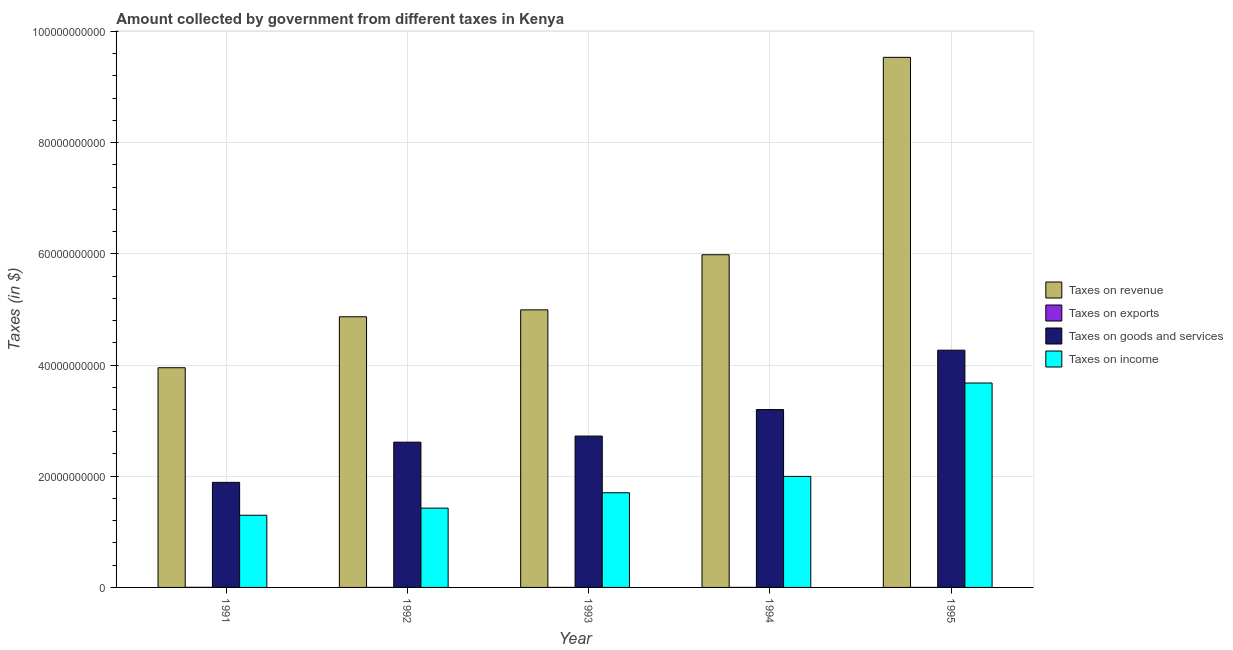Are the number of bars per tick equal to the number of legend labels?
Your answer should be compact. Yes. Are the number of bars on each tick of the X-axis equal?
Your response must be concise. Yes. In how many cases, is the number of bars for a given year not equal to the number of legend labels?
Your answer should be compact. 0. What is the amount collected as tax on income in 1991?
Offer a terse response. 1.30e+1. Across all years, what is the maximum amount collected as tax on goods?
Keep it short and to the point. 4.27e+1. Across all years, what is the minimum amount collected as tax on revenue?
Keep it short and to the point. 3.95e+1. In which year was the amount collected as tax on exports minimum?
Ensure brevity in your answer.  1993. What is the total amount collected as tax on income in the graph?
Offer a terse response. 1.01e+11. What is the difference between the amount collected as tax on goods in 1993 and that in 1994?
Keep it short and to the point. -4.77e+09. What is the difference between the amount collected as tax on goods in 1992 and the amount collected as tax on income in 1993?
Offer a terse response. -1.10e+09. What is the average amount collected as tax on revenue per year?
Offer a very short reply. 5.87e+1. In the year 1995, what is the difference between the amount collected as tax on goods and amount collected as tax on exports?
Your response must be concise. 0. In how many years, is the amount collected as tax on exports greater than 44000000000 $?
Your answer should be very brief. 0. What is the ratio of the amount collected as tax on goods in 1992 to that in 1995?
Keep it short and to the point. 0.61. Is the difference between the amount collected as tax on exports in 1993 and 1994 greater than the difference between the amount collected as tax on goods in 1993 and 1994?
Your answer should be compact. No. What is the difference between the highest and the second highest amount collected as tax on goods?
Offer a very short reply. 1.07e+1. What is the difference between the highest and the lowest amount collected as tax on income?
Your answer should be compact. 2.38e+1. What does the 4th bar from the left in 1993 represents?
Provide a succinct answer. Taxes on income. What does the 2nd bar from the right in 1995 represents?
Make the answer very short. Taxes on goods and services. Is it the case that in every year, the sum of the amount collected as tax on revenue and amount collected as tax on exports is greater than the amount collected as tax on goods?
Keep it short and to the point. Yes. How many years are there in the graph?
Your answer should be very brief. 5. Are the values on the major ticks of Y-axis written in scientific E-notation?
Make the answer very short. No. Where does the legend appear in the graph?
Provide a succinct answer. Center right. What is the title of the graph?
Ensure brevity in your answer.  Amount collected by government from different taxes in Kenya. What is the label or title of the X-axis?
Make the answer very short. Year. What is the label or title of the Y-axis?
Provide a short and direct response. Taxes (in $). What is the Taxes (in $) in Taxes on revenue in 1991?
Provide a succinct answer. 3.95e+1. What is the Taxes (in $) of Taxes on exports in 1991?
Make the answer very short. 1.50e+07. What is the Taxes (in $) in Taxes on goods and services in 1991?
Offer a very short reply. 1.89e+1. What is the Taxes (in $) in Taxes on income in 1991?
Your answer should be compact. 1.30e+1. What is the Taxes (in $) in Taxes on revenue in 1992?
Ensure brevity in your answer.  4.87e+1. What is the Taxes (in $) of Taxes on goods and services in 1992?
Make the answer very short. 2.61e+1. What is the Taxes (in $) of Taxes on income in 1992?
Ensure brevity in your answer.  1.43e+1. What is the Taxes (in $) of Taxes on revenue in 1993?
Make the answer very short. 4.99e+1. What is the Taxes (in $) of Taxes on goods and services in 1993?
Keep it short and to the point. 2.72e+1. What is the Taxes (in $) in Taxes on income in 1993?
Ensure brevity in your answer.  1.70e+1. What is the Taxes (in $) in Taxes on revenue in 1994?
Keep it short and to the point. 5.98e+1. What is the Taxes (in $) in Taxes on goods and services in 1994?
Make the answer very short. 3.20e+1. What is the Taxes (in $) of Taxes on income in 1994?
Make the answer very short. 2.00e+1. What is the Taxes (in $) in Taxes on revenue in 1995?
Offer a very short reply. 9.54e+1. What is the Taxes (in $) in Taxes on goods and services in 1995?
Provide a succinct answer. 4.27e+1. What is the Taxes (in $) in Taxes on income in 1995?
Make the answer very short. 3.68e+1. Across all years, what is the maximum Taxes (in $) of Taxes on revenue?
Give a very brief answer. 9.54e+1. Across all years, what is the maximum Taxes (in $) of Taxes on exports?
Your answer should be very brief. 1.50e+07. Across all years, what is the maximum Taxes (in $) in Taxes on goods and services?
Provide a short and direct response. 4.27e+1. Across all years, what is the maximum Taxes (in $) in Taxes on income?
Offer a very short reply. 3.68e+1. Across all years, what is the minimum Taxes (in $) in Taxes on revenue?
Your answer should be compact. 3.95e+1. Across all years, what is the minimum Taxes (in $) in Taxes on exports?
Offer a terse response. 1.00e+06. Across all years, what is the minimum Taxes (in $) of Taxes on goods and services?
Provide a short and direct response. 1.89e+1. Across all years, what is the minimum Taxes (in $) in Taxes on income?
Ensure brevity in your answer.  1.30e+1. What is the total Taxes (in $) of Taxes on revenue in the graph?
Keep it short and to the point. 2.93e+11. What is the total Taxes (in $) in Taxes on exports in the graph?
Your answer should be compact. 2.50e+07. What is the total Taxes (in $) of Taxes on goods and services in the graph?
Give a very brief answer. 1.47e+11. What is the total Taxes (in $) in Taxes on income in the graph?
Your answer should be compact. 1.01e+11. What is the difference between the Taxes (in $) in Taxes on revenue in 1991 and that in 1992?
Keep it short and to the point. -9.16e+09. What is the difference between the Taxes (in $) in Taxes on exports in 1991 and that in 1992?
Your answer should be very brief. 1.30e+07. What is the difference between the Taxes (in $) of Taxes on goods and services in 1991 and that in 1992?
Give a very brief answer. -7.23e+09. What is the difference between the Taxes (in $) in Taxes on income in 1991 and that in 1992?
Give a very brief answer. -1.28e+09. What is the difference between the Taxes (in $) of Taxes on revenue in 1991 and that in 1993?
Ensure brevity in your answer.  -1.04e+1. What is the difference between the Taxes (in $) in Taxes on exports in 1991 and that in 1993?
Your answer should be very brief. 1.40e+07. What is the difference between the Taxes (in $) of Taxes on goods and services in 1991 and that in 1993?
Your answer should be compact. -8.33e+09. What is the difference between the Taxes (in $) of Taxes on income in 1991 and that in 1993?
Your answer should be very brief. -4.04e+09. What is the difference between the Taxes (in $) in Taxes on revenue in 1991 and that in 1994?
Make the answer very short. -2.03e+1. What is the difference between the Taxes (in $) of Taxes on exports in 1991 and that in 1994?
Make the answer very short. 1.10e+07. What is the difference between the Taxes (in $) of Taxes on goods and services in 1991 and that in 1994?
Provide a succinct answer. -1.31e+1. What is the difference between the Taxes (in $) in Taxes on income in 1991 and that in 1994?
Your answer should be compact. -6.99e+09. What is the difference between the Taxes (in $) of Taxes on revenue in 1991 and that in 1995?
Keep it short and to the point. -5.58e+1. What is the difference between the Taxes (in $) of Taxes on goods and services in 1991 and that in 1995?
Ensure brevity in your answer.  -2.38e+1. What is the difference between the Taxes (in $) in Taxes on income in 1991 and that in 1995?
Your response must be concise. -2.38e+1. What is the difference between the Taxes (in $) in Taxes on revenue in 1992 and that in 1993?
Your answer should be very brief. -1.24e+09. What is the difference between the Taxes (in $) in Taxes on exports in 1992 and that in 1993?
Your answer should be compact. 1.00e+06. What is the difference between the Taxes (in $) in Taxes on goods and services in 1992 and that in 1993?
Your answer should be very brief. -1.10e+09. What is the difference between the Taxes (in $) in Taxes on income in 1992 and that in 1993?
Provide a succinct answer. -2.77e+09. What is the difference between the Taxes (in $) in Taxes on revenue in 1992 and that in 1994?
Your answer should be compact. -1.12e+1. What is the difference between the Taxes (in $) of Taxes on goods and services in 1992 and that in 1994?
Ensure brevity in your answer.  -5.86e+09. What is the difference between the Taxes (in $) of Taxes on income in 1992 and that in 1994?
Ensure brevity in your answer.  -5.71e+09. What is the difference between the Taxes (in $) of Taxes on revenue in 1992 and that in 1995?
Give a very brief answer. -4.67e+1. What is the difference between the Taxes (in $) in Taxes on exports in 1992 and that in 1995?
Your response must be concise. -1.00e+06. What is the difference between the Taxes (in $) in Taxes on goods and services in 1992 and that in 1995?
Provide a short and direct response. -1.65e+1. What is the difference between the Taxes (in $) in Taxes on income in 1992 and that in 1995?
Provide a succinct answer. -2.25e+1. What is the difference between the Taxes (in $) in Taxes on revenue in 1993 and that in 1994?
Ensure brevity in your answer.  -9.91e+09. What is the difference between the Taxes (in $) of Taxes on goods and services in 1993 and that in 1994?
Provide a short and direct response. -4.77e+09. What is the difference between the Taxes (in $) in Taxes on income in 1993 and that in 1994?
Your answer should be compact. -2.94e+09. What is the difference between the Taxes (in $) in Taxes on revenue in 1993 and that in 1995?
Your response must be concise. -4.54e+1. What is the difference between the Taxes (in $) in Taxes on exports in 1993 and that in 1995?
Your response must be concise. -2.00e+06. What is the difference between the Taxes (in $) in Taxes on goods and services in 1993 and that in 1995?
Ensure brevity in your answer.  -1.54e+1. What is the difference between the Taxes (in $) in Taxes on income in 1993 and that in 1995?
Keep it short and to the point. -1.97e+1. What is the difference between the Taxes (in $) of Taxes on revenue in 1994 and that in 1995?
Your answer should be very brief. -3.55e+1. What is the difference between the Taxes (in $) of Taxes on goods and services in 1994 and that in 1995?
Give a very brief answer. -1.07e+1. What is the difference between the Taxes (in $) in Taxes on income in 1994 and that in 1995?
Give a very brief answer. -1.68e+1. What is the difference between the Taxes (in $) in Taxes on revenue in 1991 and the Taxes (in $) in Taxes on exports in 1992?
Keep it short and to the point. 3.95e+1. What is the difference between the Taxes (in $) in Taxes on revenue in 1991 and the Taxes (in $) in Taxes on goods and services in 1992?
Ensure brevity in your answer.  1.34e+1. What is the difference between the Taxes (in $) in Taxes on revenue in 1991 and the Taxes (in $) in Taxes on income in 1992?
Offer a terse response. 2.53e+1. What is the difference between the Taxes (in $) of Taxes on exports in 1991 and the Taxes (in $) of Taxes on goods and services in 1992?
Give a very brief answer. -2.61e+1. What is the difference between the Taxes (in $) of Taxes on exports in 1991 and the Taxes (in $) of Taxes on income in 1992?
Make the answer very short. -1.42e+1. What is the difference between the Taxes (in $) of Taxes on goods and services in 1991 and the Taxes (in $) of Taxes on income in 1992?
Offer a terse response. 4.63e+09. What is the difference between the Taxes (in $) in Taxes on revenue in 1991 and the Taxes (in $) in Taxes on exports in 1993?
Make the answer very short. 3.95e+1. What is the difference between the Taxes (in $) of Taxes on revenue in 1991 and the Taxes (in $) of Taxes on goods and services in 1993?
Ensure brevity in your answer.  1.23e+1. What is the difference between the Taxes (in $) in Taxes on revenue in 1991 and the Taxes (in $) in Taxes on income in 1993?
Your answer should be compact. 2.25e+1. What is the difference between the Taxes (in $) in Taxes on exports in 1991 and the Taxes (in $) in Taxes on goods and services in 1993?
Give a very brief answer. -2.72e+1. What is the difference between the Taxes (in $) of Taxes on exports in 1991 and the Taxes (in $) of Taxes on income in 1993?
Make the answer very short. -1.70e+1. What is the difference between the Taxes (in $) in Taxes on goods and services in 1991 and the Taxes (in $) in Taxes on income in 1993?
Provide a short and direct response. 1.87e+09. What is the difference between the Taxes (in $) in Taxes on revenue in 1991 and the Taxes (in $) in Taxes on exports in 1994?
Ensure brevity in your answer.  3.95e+1. What is the difference between the Taxes (in $) in Taxes on revenue in 1991 and the Taxes (in $) in Taxes on goods and services in 1994?
Your response must be concise. 7.53e+09. What is the difference between the Taxes (in $) of Taxes on revenue in 1991 and the Taxes (in $) of Taxes on income in 1994?
Keep it short and to the point. 1.95e+1. What is the difference between the Taxes (in $) of Taxes on exports in 1991 and the Taxes (in $) of Taxes on goods and services in 1994?
Give a very brief answer. -3.20e+1. What is the difference between the Taxes (in $) in Taxes on exports in 1991 and the Taxes (in $) in Taxes on income in 1994?
Keep it short and to the point. -2.00e+1. What is the difference between the Taxes (in $) of Taxes on goods and services in 1991 and the Taxes (in $) of Taxes on income in 1994?
Offer a very short reply. -1.07e+09. What is the difference between the Taxes (in $) of Taxes on revenue in 1991 and the Taxes (in $) of Taxes on exports in 1995?
Your answer should be compact. 3.95e+1. What is the difference between the Taxes (in $) of Taxes on revenue in 1991 and the Taxes (in $) of Taxes on goods and services in 1995?
Your response must be concise. -3.16e+09. What is the difference between the Taxes (in $) of Taxes on revenue in 1991 and the Taxes (in $) of Taxes on income in 1995?
Provide a short and direct response. 2.75e+09. What is the difference between the Taxes (in $) in Taxes on exports in 1991 and the Taxes (in $) in Taxes on goods and services in 1995?
Offer a terse response. -4.27e+1. What is the difference between the Taxes (in $) of Taxes on exports in 1991 and the Taxes (in $) of Taxes on income in 1995?
Provide a short and direct response. -3.68e+1. What is the difference between the Taxes (in $) of Taxes on goods and services in 1991 and the Taxes (in $) of Taxes on income in 1995?
Keep it short and to the point. -1.79e+1. What is the difference between the Taxes (in $) in Taxes on revenue in 1992 and the Taxes (in $) in Taxes on exports in 1993?
Your response must be concise. 4.87e+1. What is the difference between the Taxes (in $) in Taxes on revenue in 1992 and the Taxes (in $) in Taxes on goods and services in 1993?
Provide a short and direct response. 2.15e+1. What is the difference between the Taxes (in $) in Taxes on revenue in 1992 and the Taxes (in $) in Taxes on income in 1993?
Provide a succinct answer. 3.17e+1. What is the difference between the Taxes (in $) of Taxes on exports in 1992 and the Taxes (in $) of Taxes on goods and services in 1993?
Your answer should be very brief. -2.72e+1. What is the difference between the Taxes (in $) of Taxes on exports in 1992 and the Taxes (in $) of Taxes on income in 1993?
Your answer should be very brief. -1.70e+1. What is the difference between the Taxes (in $) of Taxes on goods and services in 1992 and the Taxes (in $) of Taxes on income in 1993?
Keep it short and to the point. 9.10e+09. What is the difference between the Taxes (in $) in Taxes on revenue in 1992 and the Taxes (in $) in Taxes on exports in 1994?
Offer a terse response. 4.87e+1. What is the difference between the Taxes (in $) of Taxes on revenue in 1992 and the Taxes (in $) of Taxes on goods and services in 1994?
Your response must be concise. 1.67e+1. What is the difference between the Taxes (in $) of Taxes on revenue in 1992 and the Taxes (in $) of Taxes on income in 1994?
Offer a very short reply. 2.87e+1. What is the difference between the Taxes (in $) of Taxes on exports in 1992 and the Taxes (in $) of Taxes on goods and services in 1994?
Your response must be concise. -3.20e+1. What is the difference between the Taxes (in $) in Taxes on exports in 1992 and the Taxes (in $) in Taxes on income in 1994?
Make the answer very short. -2.00e+1. What is the difference between the Taxes (in $) in Taxes on goods and services in 1992 and the Taxes (in $) in Taxes on income in 1994?
Offer a terse response. 6.16e+09. What is the difference between the Taxes (in $) in Taxes on revenue in 1992 and the Taxes (in $) in Taxes on exports in 1995?
Keep it short and to the point. 4.87e+1. What is the difference between the Taxes (in $) of Taxes on revenue in 1992 and the Taxes (in $) of Taxes on goods and services in 1995?
Make the answer very short. 6.01e+09. What is the difference between the Taxes (in $) of Taxes on revenue in 1992 and the Taxes (in $) of Taxes on income in 1995?
Provide a succinct answer. 1.19e+1. What is the difference between the Taxes (in $) in Taxes on exports in 1992 and the Taxes (in $) in Taxes on goods and services in 1995?
Ensure brevity in your answer.  -4.27e+1. What is the difference between the Taxes (in $) of Taxes on exports in 1992 and the Taxes (in $) of Taxes on income in 1995?
Your answer should be very brief. -3.68e+1. What is the difference between the Taxes (in $) of Taxes on goods and services in 1992 and the Taxes (in $) of Taxes on income in 1995?
Make the answer very short. -1.06e+1. What is the difference between the Taxes (in $) in Taxes on revenue in 1993 and the Taxes (in $) in Taxes on exports in 1994?
Your answer should be compact. 4.99e+1. What is the difference between the Taxes (in $) in Taxes on revenue in 1993 and the Taxes (in $) in Taxes on goods and services in 1994?
Your response must be concise. 1.79e+1. What is the difference between the Taxes (in $) of Taxes on revenue in 1993 and the Taxes (in $) of Taxes on income in 1994?
Give a very brief answer. 3.00e+1. What is the difference between the Taxes (in $) of Taxes on exports in 1993 and the Taxes (in $) of Taxes on goods and services in 1994?
Make the answer very short. -3.20e+1. What is the difference between the Taxes (in $) of Taxes on exports in 1993 and the Taxes (in $) of Taxes on income in 1994?
Make the answer very short. -2.00e+1. What is the difference between the Taxes (in $) in Taxes on goods and services in 1993 and the Taxes (in $) in Taxes on income in 1994?
Offer a terse response. 7.26e+09. What is the difference between the Taxes (in $) in Taxes on revenue in 1993 and the Taxes (in $) in Taxes on exports in 1995?
Make the answer very short. 4.99e+1. What is the difference between the Taxes (in $) of Taxes on revenue in 1993 and the Taxes (in $) of Taxes on goods and services in 1995?
Make the answer very short. 7.25e+09. What is the difference between the Taxes (in $) of Taxes on revenue in 1993 and the Taxes (in $) of Taxes on income in 1995?
Make the answer very short. 1.32e+1. What is the difference between the Taxes (in $) in Taxes on exports in 1993 and the Taxes (in $) in Taxes on goods and services in 1995?
Your response must be concise. -4.27e+1. What is the difference between the Taxes (in $) in Taxes on exports in 1993 and the Taxes (in $) in Taxes on income in 1995?
Your answer should be very brief. -3.68e+1. What is the difference between the Taxes (in $) of Taxes on goods and services in 1993 and the Taxes (in $) of Taxes on income in 1995?
Offer a very short reply. -9.54e+09. What is the difference between the Taxes (in $) of Taxes on revenue in 1994 and the Taxes (in $) of Taxes on exports in 1995?
Provide a short and direct response. 5.98e+1. What is the difference between the Taxes (in $) of Taxes on revenue in 1994 and the Taxes (in $) of Taxes on goods and services in 1995?
Give a very brief answer. 1.72e+1. What is the difference between the Taxes (in $) of Taxes on revenue in 1994 and the Taxes (in $) of Taxes on income in 1995?
Provide a succinct answer. 2.31e+1. What is the difference between the Taxes (in $) in Taxes on exports in 1994 and the Taxes (in $) in Taxes on goods and services in 1995?
Your response must be concise. -4.27e+1. What is the difference between the Taxes (in $) in Taxes on exports in 1994 and the Taxes (in $) in Taxes on income in 1995?
Offer a very short reply. -3.68e+1. What is the difference between the Taxes (in $) of Taxes on goods and services in 1994 and the Taxes (in $) of Taxes on income in 1995?
Offer a terse response. -4.78e+09. What is the average Taxes (in $) in Taxes on revenue per year?
Make the answer very short. 5.87e+1. What is the average Taxes (in $) in Taxes on goods and services per year?
Your response must be concise. 2.94e+1. What is the average Taxes (in $) in Taxes on income per year?
Make the answer very short. 2.02e+1. In the year 1991, what is the difference between the Taxes (in $) of Taxes on revenue and Taxes (in $) of Taxes on exports?
Offer a terse response. 3.95e+1. In the year 1991, what is the difference between the Taxes (in $) in Taxes on revenue and Taxes (in $) in Taxes on goods and services?
Your answer should be compact. 2.06e+1. In the year 1991, what is the difference between the Taxes (in $) in Taxes on revenue and Taxes (in $) in Taxes on income?
Your response must be concise. 2.65e+1. In the year 1991, what is the difference between the Taxes (in $) in Taxes on exports and Taxes (in $) in Taxes on goods and services?
Your answer should be compact. -1.89e+1. In the year 1991, what is the difference between the Taxes (in $) in Taxes on exports and Taxes (in $) in Taxes on income?
Your answer should be compact. -1.30e+1. In the year 1991, what is the difference between the Taxes (in $) in Taxes on goods and services and Taxes (in $) in Taxes on income?
Keep it short and to the point. 5.91e+09. In the year 1992, what is the difference between the Taxes (in $) of Taxes on revenue and Taxes (in $) of Taxes on exports?
Make the answer very short. 4.87e+1. In the year 1992, what is the difference between the Taxes (in $) in Taxes on revenue and Taxes (in $) in Taxes on goods and services?
Your answer should be compact. 2.26e+1. In the year 1992, what is the difference between the Taxes (in $) of Taxes on revenue and Taxes (in $) of Taxes on income?
Offer a terse response. 3.44e+1. In the year 1992, what is the difference between the Taxes (in $) of Taxes on exports and Taxes (in $) of Taxes on goods and services?
Make the answer very short. -2.61e+1. In the year 1992, what is the difference between the Taxes (in $) of Taxes on exports and Taxes (in $) of Taxes on income?
Make the answer very short. -1.43e+1. In the year 1992, what is the difference between the Taxes (in $) of Taxes on goods and services and Taxes (in $) of Taxes on income?
Make the answer very short. 1.19e+1. In the year 1993, what is the difference between the Taxes (in $) of Taxes on revenue and Taxes (in $) of Taxes on exports?
Ensure brevity in your answer.  4.99e+1. In the year 1993, what is the difference between the Taxes (in $) of Taxes on revenue and Taxes (in $) of Taxes on goods and services?
Your response must be concise. 2.27e+1. In the year 1993, what is the difference between the Taxes (in $) of Taxes on revenue and Taxes (in $) of Taxes on income?
Your answer should be compact. 3.29e+1. In the year 1993, what is the difference between the Taxes (in $) of Taxes on exports and Taxes (in $) of Taxes on goods and services?
Keep it short and to the point. -2.72e+1. In the year 1993, what is the difference between the Taxes (in $) in Taxes on exports and Taxes (in $) in Taxes on income?
Your answer should be very brief. -1.70e+1. In the year 1993, what is the difference between the Taxes (in $) of Taxes on goods and services and Taxes (in $) of Taxes on income?
Keep it short and to the point. 1.02e+1. In the year 1994, what is the difference between the Taxes (in $) of Taxes on revenue and Taxes (in $) of Taxes on exports?
Give a very brief answer. 5.98e+1. In the year 1994, what is the difference between the Taxes (in $) of Taxes on revenue and Taxes (in $) of Taxes on goods and services?
Your answer should be compact. 2.78e+1. In the year 1994, what is the difference between the Taxes (in $) of Taxes on revenue and Taxes (in $) of Taxes on income?
Provide a short and direct response. 3.99e+1. In the year 1994, what is the difference between the Taxes (in $) of Taxes on exports and Taxes (in $) of Taxes on goods and services?
Give a very brief answer. -3.20e+1. In the year 1994, what is the difference between the Taxes (in $) in Taxes on exports and Taxes (in $) in Taxes on income?
Your answer should be compact. -2.00e+1. In the year 1994, what is the difference between the Taxes (in $) in Taxes on goods and services and Taxes (in $) in Taxes on income?
Offer a very short reply. 1.20e+1. In the year 1995, what is the difference between the Taxes (in $) of Taxes on revenue and Taxes (in $) of Taxes on exports?
Provide a short and direct response. 9.53e+1. In the year 1995, what is the difference between the Taxes (in $) in Taxes on revenue and Taxes (in $) in Taxes on goods and services?
Provide a short and direct response. 5.27e+1. In the year 1995, what is the difference between the Taxes (in $) of Taxes on revenue and Taxes (in $) of Taxes on income?
Offer a very short reply. 5.86e+1. In the year 1995, what is the difference between the Taxes (in $) in Taxes on exports and Taxes (in $) in Taxes on goods and services?
Your answer should be compact. -4.27e+1. In the year 1995, what is the difference between the Taxes (in $) in Taxes on exports and Taxes (in $) in Taxes on income?
Your response must be concise. -3.68e+1. In the year 1995, what is the difference between the Taxes (in $) in Taxes on goods and services and Taxes (in $) in Taxes on income?
Provide a short and direct response. 5.91e+09. What is the ratio of the Taxes (in $) in Taxes on revenue in 1991 to that in 1992?
Give a very brief answer. 0.81. What is the ratio of the Taxes (in $) of Taxes on goods and services in 1991 to that in 1992?
Provide a succinct answer. 0.72. What is the ratio of the Taxes (in $) in Taxes on income in 1991 to that in 1992?
Provide a succinct answer. 0.91. What is the ratio of the Taxes (in $) in Taxes on revenue in 1991 to that in 1993?
Give a very brief answer. 0.79. What is the ratio of the Taxes (in $) in Taxes on exports in 1991 to that in 1993?
Your response must be concise. 15. What is the ratio of the Taxes (in $) in Taxes on goods and services in 1991 to that in 1993?
Keep it short and to the point. 0.69. What is the ratio of the Taxes (in $) in Taxes on income in 1991 to that in 1993?
Make the answer very short. 0.76. What is the ratio of the Taxes (in $) of Taxes on revenue in 1991 to that in 1994?
Ensure brevity in your answer.  0.66. What is the ratio of the Taxes (in $) of Taxes on exports in 1991 to that in 1994?
Provide a short and direct response. 3.75. What is the ratio of the Taxes (in $) of Taxes on goods and services in 1991 to that in 1994?
Keep it short and to the point. 0.59. What is the ratio of the Taxes (in $) of Taxes on income in 1991 to that in 1994?
Offer a terse response. 0.65. What is the ratio of the Taxes (in $) of Taxes on revenue in 1991 to that in 1995?
Keep it short and to the point. 0.41. What is the ratio of the Taxes (in $) in Taxes on exports in 1991 to that in 1995?
Your answer should be very brief. 5. What is the ratio of the Taxes (in $) in Taxes on goods and services in 1991 to that in 1995?
Make the answer very short. 0.44. What is the ratio of the Taxes (in $) of Taxes on income in 1991 to that in 1995?
Give a very brief answer. 0.35. What is the ratio of the Taxes (in $) in Taxes on revenue in 1992 to that in 1993?
Your answer should be very brief. 0.98. What is the ratio of the Taxes (in $) in Taxes on goods and services in 1992 to that in 1993?
Offer a terse response. 0.96. What is the ratio of the Taxes (in $) of Taxes on income in 1992 to that in 1993?
Offer a terse response. 0.84. What is the ratio of the Taxes (in $) of Taxes on revenue in 1992 to that in 1994?
Keep it short and to the point. 0.81. What is the ratio of the Taxes (in $) of Taxes on exports in 1992 to that in 1994?
Offer a very short reply. 0.5. What is the ratio of the Taxes (in $) in Taxes on goods and services in 1992 to that in 1994?
Give a very brief answer. 0.82. What is the ratio of the Taxes (in $) of Taxes on income in 1992 to that in 1994?
Your answer should be very brief. 0.71. What is the ratio of the Taxes (in $) of Taxes on revenue in 1992 to that in 1995?
Your answer should be very brief. 0.51. What is the ratio of the Taxes (in $) of Taxes on exports in 1992 to that in 1995?
Your response must be concise. 0.67. What is the ratio of the Taxes (in $) in Taxes on goods and services in 1992 to that in 1995?
Your answer should be compact. 0.61. What is the ratio of the Taxes (in $) in Taxes on income in 1992 to that in 1995?
Ensure brevity in your answer.  0.39. What is the ratio of the Taxes (in $) of Taxes on revenue in 1993 to that in 1994?
Offer a terse response. 0.83. What is the ratio of the Taxes (in $) in Taxes on goods and services in 1993 to that in 1994?
Offer a terse response. 0.85. What is the ratio of the Taxes (in $) in Taxes on income in 1993 to that in 1994?
Give a very brief answer. 0.85. What is the ratio of the Taxes (in $) in Taxes on revenue in 1993 to that in 1995?
Make the answer very short. 0.52. What is the ratio of the Taxes (in $) in Taxes on exports in 1993 to that in 1995?
Make the answer very short. 0.33. What is the ratio of the Taxes (in $) in Taxes on goods and services in 1993 to that in 1995?
Keep it short and to the point. 0.64. What is the ratio of the Taxes (in $) in Taxes on income in 1993 to that in 1995?
Provide a short and direct response. 0.46. What is the ratio of the Taxes (in $) in Taxes on revenue in 1994 to that in 1995?
Ensure brevity in your answer.  0.63. What is the ratio of the Taxes (in $) of Taxes on exports in 1994 to that in 1995?
Offer a terse response. 1.33. What is the ratio of the Taxes (in $) of Taxes on goods and services in 1994 to that in 1995?
Your response must be concise. 0.75. What is the ratio of the Taxes (in $) of Taxes on income in 1994 to that in 1995?
Provide a succinct answer. 0.54. What is the difference between the highest and the second highest Taxes (in $) in Taxes on revenue?
Offer a very short reply. 3.55e+1. What is the difference between the highest and the second highest Taxes (in $) of Taxes on exports?
Offer a very short reply. 1.10e+07. What is the difference between the highest and the second highest Taxes (in $) of Taxes on goods and services?
Provide a succinct answer. 1.07e+1. What is the difference between the highest and the second highest Taxes (in $) in Taxes on income?
Offer a very short reply. 1.68e+1. What is the difference between the highest and the lowest Taxes (in $) in Taxes on revenue?
Your answer should be very brief. 5.58e+1. What is the difference between the highest and the lowest Taxes (in $) in Taxes on exports?
Offer a terse response. 1.40e+07. What is the difference between the highest and the lowest Taxes (in $) in Taxes on goods and services?
Make the answer very short. 2.38e+1. What is the difference between the highest and the lowest Taxes (in $) of Taxes on income?
Ensure brevity in your answer.  2.38e+1. 